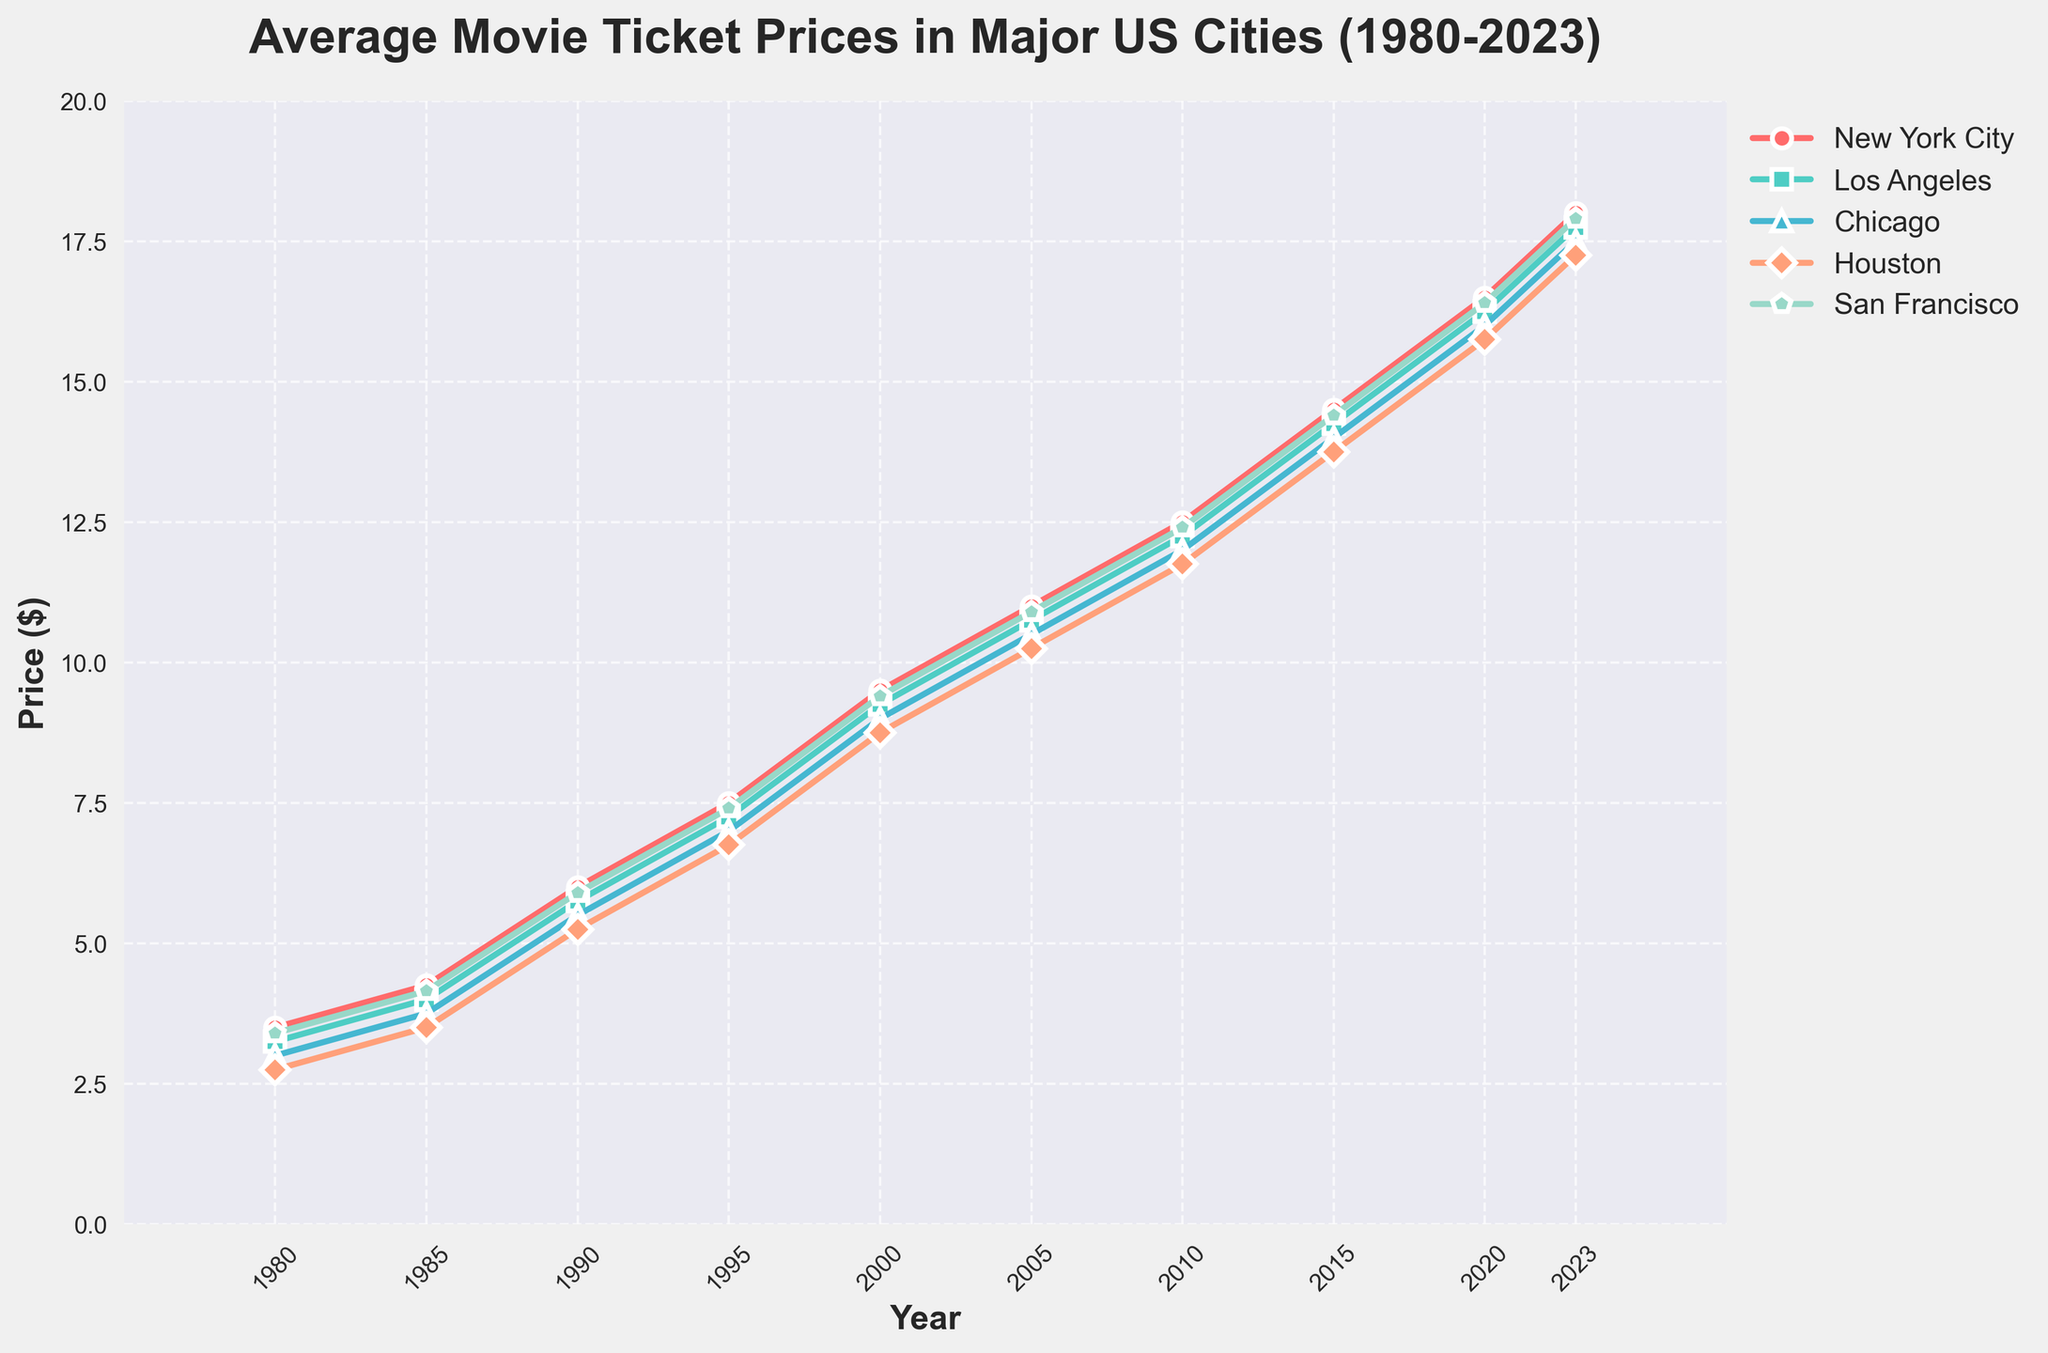What was the average movie ticket price in New York City in 2000? According to the line chart, locate the data point for New York City in the year 2000. The ticket price is marked as $9.50.
Answer: $9.50 Which city had the highest average movie ticket price in 2023? By examining the endpoints of the lines in 2023, we see New York City has the highest average ticket price compared to other cities.
Answer: New York City How much did the average movie ticket price in Los Angeles increase from 1980 to 2023? To find the increase, subtract the 1980 value from the 2023 value for Los Angeles. It increased from $3.25 in 1980 to $17.75 in 2023. The difference is $17.75 - $3.25 = $14.50.
Answer: $14.50 Which city had the smallest increase in movie ticket prices from 1980 to 2023? Calculate the increase for each city by subtracting the 1980 value from the 2023 value, and compare them: New York City: $18.00 - $3.50 = $14.50, Los Angeles: $17.75 - $3.25 = $14.50, Chicago: $17.50 - $3.00 = $14.50, Houston: $17.25 - $2.75 = $14.50, San Francisco: $17.90 - $3.40 = $14.50. The differences are identical, so all cities had the same increase.
Answer: All cities What’s the average movie ticket price across all cities in 2010? Add the average ticket prices for 2010 from all cities and divide by the number of cities: ($12.50 + $12.25 + $12.00 + $11.75 + $12.40)/5 = $60.90/5.
Answer: $12.18 Between which consecutive years did Houston see the largest increase in ticket prices? Calculate the difference in Houston's ticket prices between consecutive years: 1980-1985: $3.50 - $2.75 = $0.75, 1985-1990: $5.25 - $3.50 = $1.75, 1990-1995: $6.75 - $5.25 = $1.50, 1995-2000: $8.75 - $6.75 = $2.00, 2000-2005: $10.25 - $8.75 = $1.50, 2005-2010: $11.75 - $10.25 = $1.50, 2010-2015: $13.75 - $11.75 = $2.00, 2015-2020: $15.75 - $13.75 = $2.00, 2020-2023: $17.25 - $15.75 = $1.50. The largest increase happened between 1995-2000, 2010-2015, and 2015-2020, which are all $2.00.
Answer: 1995-2000, 2010-2015, 2015-2020 In which year did movie ticket prices surpass $10 in Chicago? By tracing the line for Chicago, observe around 2005, the price surpasses $10.00.
Answer: 2005 What is the difference in the average ticket price between San Francisco and Houston in 2023? Subtract the 2023 value of Houston from San Francisco: $17.90 - $17.25 = $0.65.
Answer: $0.65 